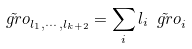Convert formula to latex. <formula><loc_0><loc_0><loc_500><loc_500>\tilde { \ g r o } _ { l _ { 1 } , \cdots , l _ { k + 2 } } = \sum _ { i } l _ { i } \tilde { \ g r o } _ { i }</formula> 